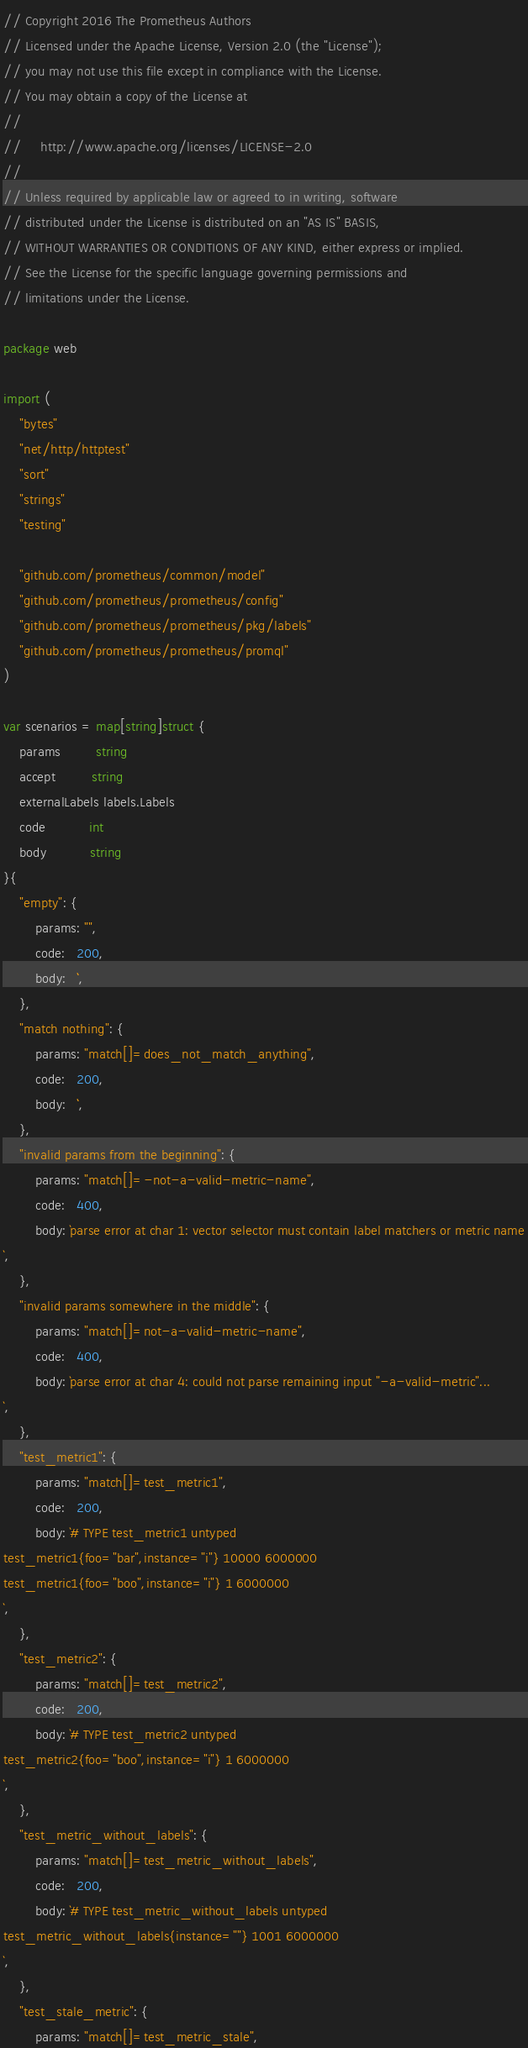<code> <loc_0><loc_0><loc_500><loc_500><_Go_>// Copyright 2016 The Prometheus Authors
// Licensed under the Apache License, Version 2.0 (the "License");
// you may not use this file except in compliance with the License.
// You may obtain a copy of the License at
//
//     http://www.apache.org/licenses/LICENSE-2.0
//
// Unless required by applicable law or agreed to in writing, software
// distributed under the License is distributed on an "AS IS" BASIS,
// WITHOUT WARRANTIES OR CONDITIONS OF ANY KIND, either express or implied.
// See the License for the specific language governing permissions and
// limitations under the License.

package web

import (
	"bytes"
	"net/http/httptest"
	"sort"
	"strings"
	"testing"

	"github.com/prometheus/common/model"
	"github.com/prometheus/prometheus/config"
	"github.com/prometheus/prometheus/pkg/labels"
	"github.com/prometheus/prometheus/promql"
)

var scenarios = map[string]struct {
	params         string
	accept         string
	externalLabels labels.Labels
	code           int
	body           string
}{
	"empty": {
		params: "",
		code:   200,
		body:   ``,
	},
	"match nothing": {
		params: "match[]=does_not_match_anything",
		code:   200,
		body:   ``,
	},
	"invalid params from the beginning": {
		params: "match[]=-not-a-valid-metric-name",
		code:   400,
		body: `parse error at char 1: vector selector must contain label matchers or metric name
`,
	},
	"invalid params somewhere in the middle": {
		params: "match[]=not-a-valid-metric-name",
		code:   400,
		body: `parse error at char 4: could not parse remaining input "-a-valid-metric"...
`,
	},
	"test_metric1": {
		params: "match[]=test_metric1",
		code:   200,
		body: `# TYPE test_metric1 untyped
test_metric1{foo="bar",instance="i"} 10000 6000000
test_metric1{foo="boo",instance="i"} 1 6000000
`,
	},
	"test_metric2": {
		params: "match[]=test_metric2",
		code:   200,
		body: `# TYPE test_metric2 untyped
test_metric2{foo="boo",instance="i"} 1 6000000
`,
	},
	"test_metric_without_labels": {
		params: "match[]=test_metric_without_labels",
		code:   200,
		body: `# TYPE test_metric_without_labels untyped
test_metric_without_labels{instance=""} 1001 6000000
`,
	},
	"test_stale_metric": {
		params: "match[]=test_metric_stale",</code> 